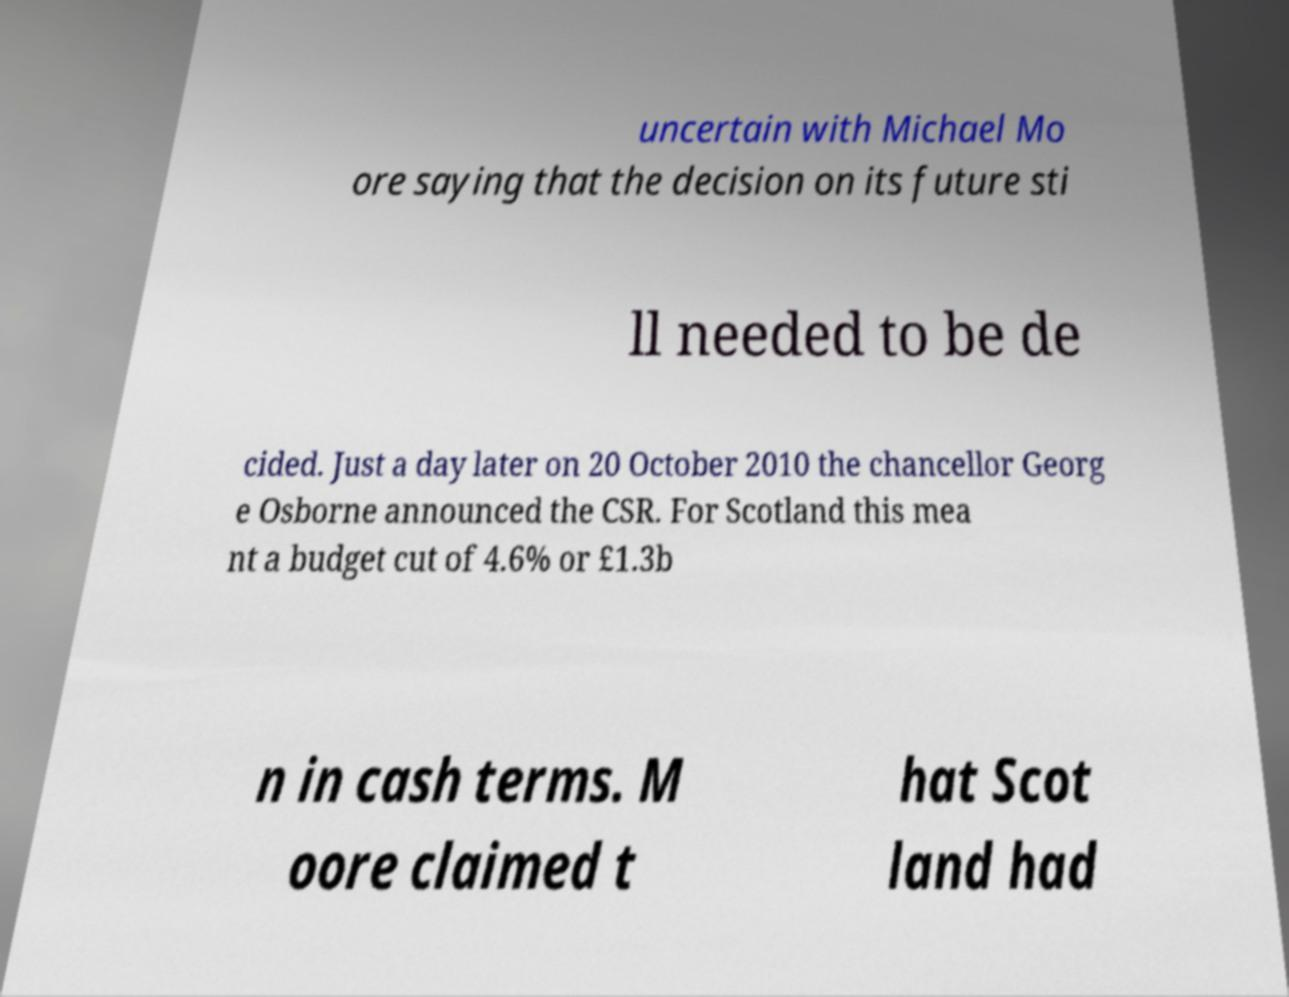I need the written content from this picture converted into text. Can you do that? uncertain with Michael Mo ore saying that the decision on its future sti ll needed to be de cided. Just a day later on 20 October 2010 the chancellor Georg e Osborne announced the CSR. For Scotland this mea nt a budget cut of 4.6% or £1.3b n in cash terms. M oore claimed t hat Scot land had 